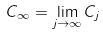Convert formula to latex. <formula><loc_0><loc_0><loc_500><loc_500>C _ { \infty } = \lim _ { j \rightarrow \infty } C _ { j }</formula> 